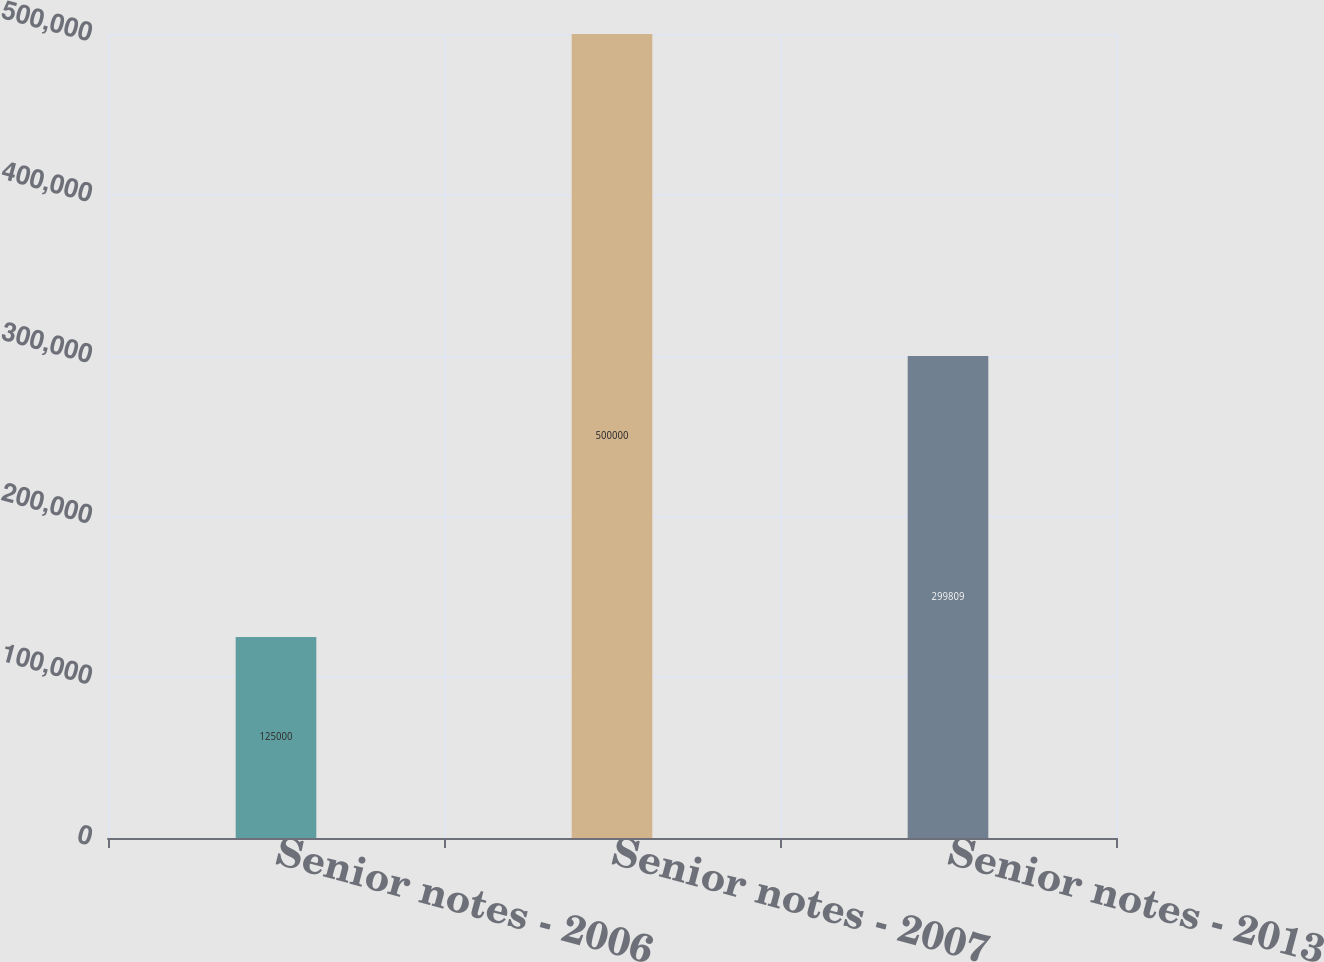Convert chart. <chart><loc_0><loc_0><loc_500><loc_500><bar_chart><fcel>Senior notes - 2006<fcel>Senior notes - 2007<fcel>Senior notes - 2013<nl><fcel>125000<fcel>500000<fcel>299809<nl></chart> 